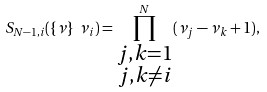<formula> <loc_0><loc_0><loc_500><loc_500>S _ { N - 1 , i } ( \{ \nu \} \ \nu _ { i } ) = \prod _ { \substack { j , k = 1 \\ j , k \ne i } } ^ { N } ( \nu _ { j } - \nu _ { k } + 1 ) ,</formula> 